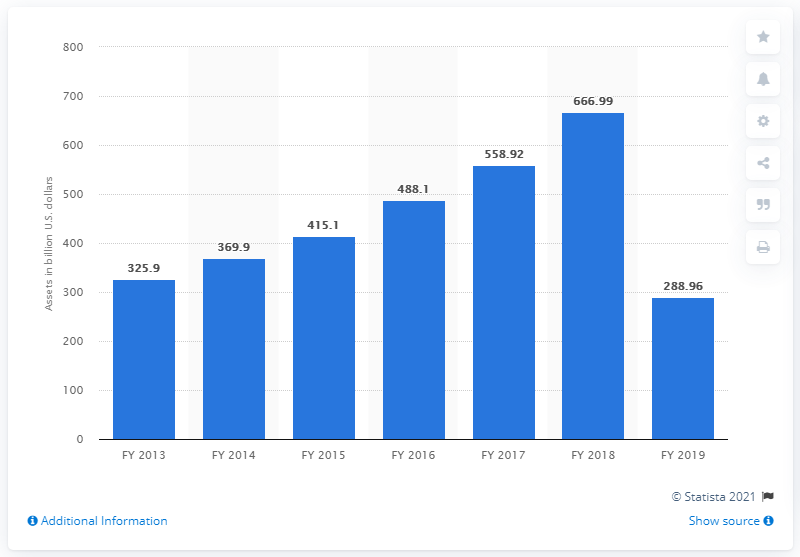Specify some key components in this picture. As of March 2018, a significant portion of bad loans, or non-performing assets (NPAs), made up 288.96% of the total loan portfolio. Private banks in India were valued at approximately 288.96 billion dollars in 2019. 